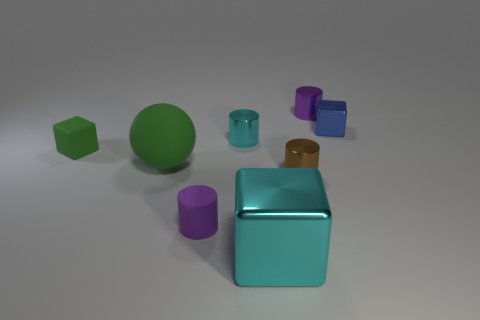Add 2 big purple metal spheres. How many objects exist? 10 Subtract all spheres. How many objects are left? 7 Subtract all blue cubes. Subtract all large things. How many objects are left? 5 Add 1 matte objects. How many matte objects are left? 4 Add 6 brown shiny objects. How many brown shiny objects exist? 7 Subtract 0 gray cylinders. How many objects are left? 8 